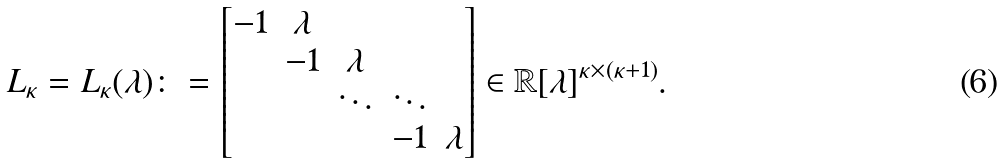Convert formula to latex. <formula><loc_0><loc_0><loc_500><loc_500>L _ { \kappa } = L _ { \kappa } ( \lambda ) \colon = \begin{bmatrix} - 1 & \lambda & & & \\ & - 1 & \lambda & & \\ & & \ddots & \ddots & \\ & & & - 1 & \lambda \end{bmatrix} \in \mathbb { R } [ \lambda ] ^ { \kappa \times ( \kappa + 1 ) } .</formula> 